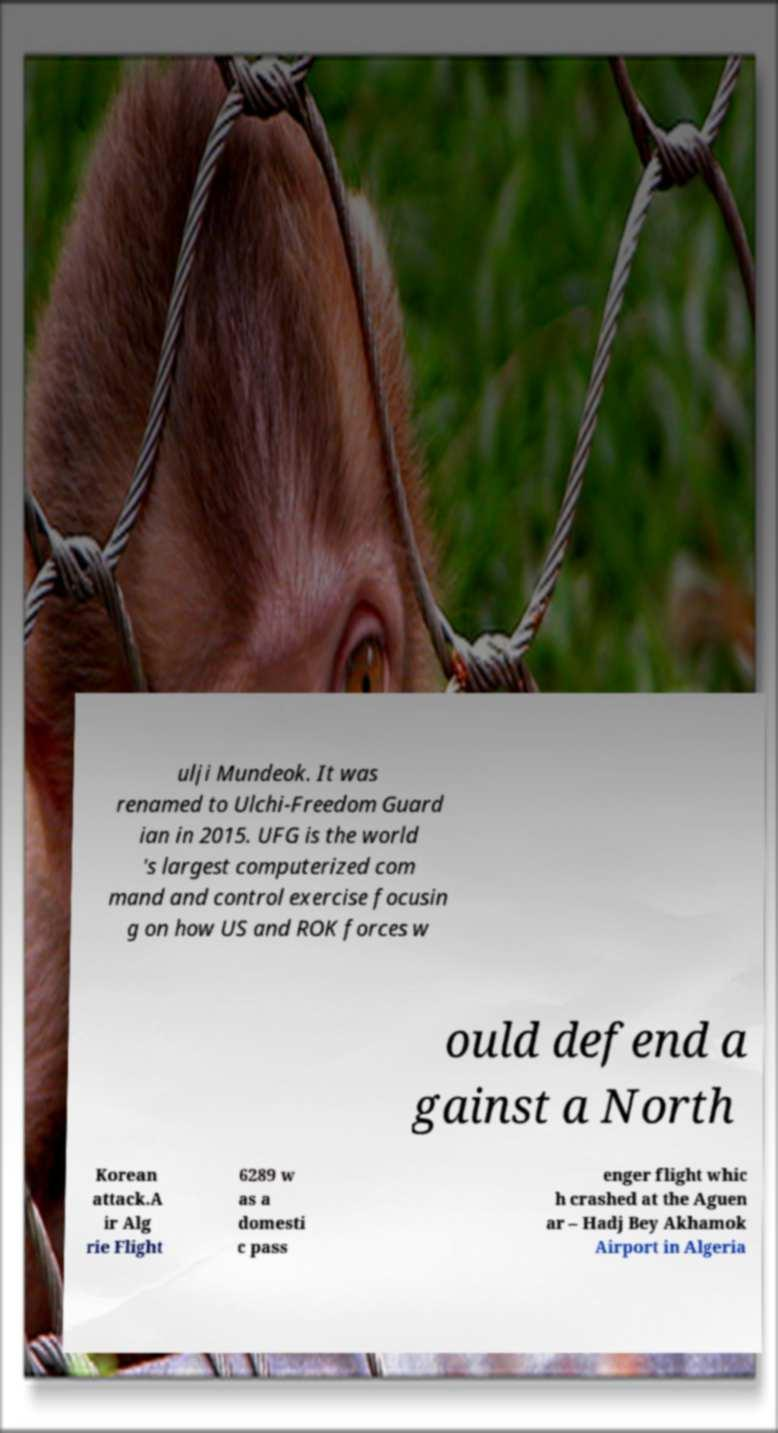What messages or text are displayed in this image? I need them in a readable, typed format. ulji Mundeok. It was renamed to Ulchi-Freedom Guard ian in 2015. UFG is the world 's largest computerized com mand and control exercise focusin g on how US and ROK forces w ould defend a gainst a North Korean attack.A ir Alg rie Flight 6289 w as a domesti c pass enger flight whic h crashed at the Aguen ar – Hadj Bey Akhamok Airport in Algeria 